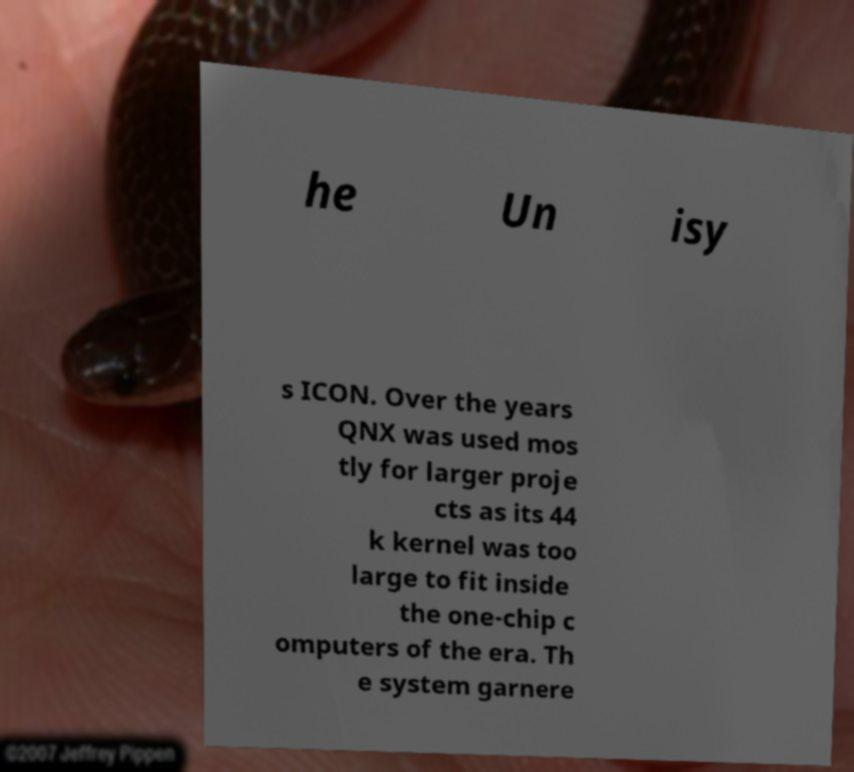Could you extract and type out the text from this image? he Un isy s ICON. Over the years QNX was used mos tly for larger proje cts as its 44 k kernel was too large to fit inside the one-chip c omputers of the era. Th e system garnere 